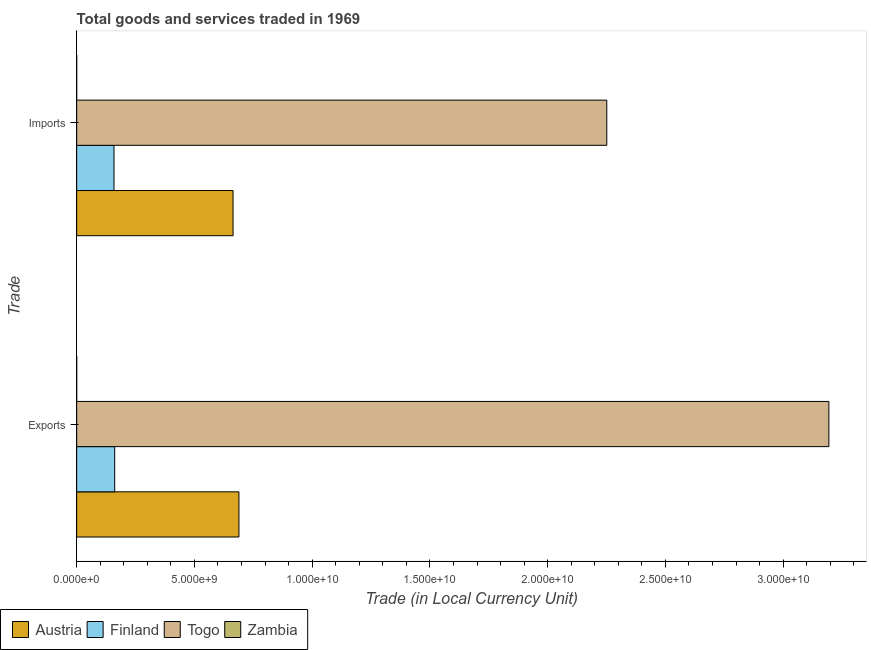How many groups of bars are there?
Keep it short and to the point. 2. How many bars are there on the 2nd tick from the bottom?
Your answer should be very brief. 4. What is the label of the 2nd group of bars from the top?
Ensure brevity in your answer.  Exports. What is the imports of goods and services in Togo?
Give a very brief answer. 2.25e+1. Across all countries, what is the maximum imports of goods and services?
Offer a terse response. 2.25e+1. Across all countries, what is the minimum export of goods and services?
Your response must be concise. 8.63e+05. In which country was the export of goods and services maximum?
Your response must be concise. Togo. In which country was the export of goods and services minimum?
Make the answer very short. Zambia. What is the total imports of goods and services in the graph?
Provide a succinct answer. 3.07e+1. What is the difference between the export of goods and services in Zambia and that in Austria?
Your response must be concise. -6.89e+09. What is the difference between the imports of goods and services in Finland and the export of goods and services in Austria?
Provide a short and direct response. -5.31e+09. What is the average export of goods and services per country?
Give a very brief answer. 1.01e+1. What is the difference between the export of goods and services and imports of goods and services in Zambia?
Provide a succinct answer. 4.37e+05. In how many countries, is the imports of goods and services greater than 7000000000 LCU?
Your answer should be very brief. 1. What is the ratio of the export of goods and services in Finland to that in Austria?
Give a very brief answer. 0.23. Is the export of goods and services in Finland less than that in Austria?
Provide a short and direct response. Yes. In how many countries, is the export of goods and services greater than the average export of goods and services taken over all countries?
Give a very brief answer. 1. What does the 4th bar from the top in Imports represents?
Your answer should be compact. Austria. What does the 4th bar from the bottom in Exports represents?
Offer a terse response. Zambia. Are all the bars in the graph horizontal?
Make the answer very short. Yes. What is the difference between two consecutive major ticks on the X-axis?
Give a very brief answer. 5.00e+09. Does the graph contain any zero values?
Your response must be concise. No. What is the title of the graph?
Your answer should be very brief. Total goods and services traded in 1969. What is the label or title of the X-axis?
Your answer should be compact. Trade (in Local Currency Unit). What is the label or title of the Y-axis?
Your response must be concise. Trade. What is the Trade (in Local Currency Unit) in Austria in Exports?
Keep it short and to the point. 6.89e+09. What is the Trade (in Local Currency Unit) in Finland in Exports?
Your response must be concise. 1.62e+09. What is the Trade (in Local Currency Unit) of Togo in Exports?
Ensure brevity in your answer.  3.19e+1. What is the Trade (in Local Currency Unit) of Zambia in Exports?
Your answer should be very brief. 8.63e+05. What is the Trade (in Local Currency Unit) of Austria in Imports?
Provide a succinct answer. 6.64e+09. What is the Trade (in Local Currency Unit) of Finland in Imports?
Your answer should be compact. 1.58e+09. What is the Trade (in Local Currency Unit) of Togo in Imports?
Ensure brevity in your answer.  2.25e+1. What is the Trade (in Local Currency Unit) in Zambia in Imports?
Give a very brief answer. 4.26e+05. Across all Trade, what is the maximum Trade (in Local Currency Unit) in Austria?
Your answer should be compact. 6.89e+09. Across all Trade, what is the maximum Trade (in Local Currency Unit) of Finland?
Provide a succinct answer. 1.62e+09. Across all Trade, what is the maximum Trade (in Local Currency Unit) of Togo?
Ensure brevity in your answer.  3.19e+1. Across all Trade, what is the maximum Trade (in Local Currency Unit) in Zambia?
Your answer should be very brief. 8.63e+05. Across all Trade, what is the minimum Trade (in Local Currency Unit) of Austria?
Make the answer very short. 6.64e+09. Across all Trade, what is the minimum Trade (in Local Currency Unit) in Finland?
Provide a succinct answer. 1.58e+09. Across all Trade, what is the minimum Trade (in Local Currency Unit) of Togo?
Ensure brevity in your answer.  2.25e+1. Across all Trade, what is the minimum Trade (in Local Currency Unit) in Zambia?
Give a very brief answer. 4.26e+05. What is the total Trade (in Local Currency Unit) in Austria in the graph?
Your response must be concise. 1.35e+1. What is the total Trade (in Local Currency Unit) in Finland in the graph?
Your answer should be compact. 3.20e+09. What is the total Trade (in Local Currency Unit) of Togo in the graph?
Offer a very short reply. 5.45e+1. What is the total Trade (in Local Currency Unit) of Zambia in the graph?
Your response must be concise. 1.29e+06. What is the difference between the Trade (in Local Currency Unit) in Austria in Exports and that in Imports?
Ensure brevity in your answer.  2.49e+08. What is the difference between the Trade (in Local Currency Unit) in Finland in Exports and that in Imports?
Your response must be concise. 3.02e+07. What is the difference between the Trade (in Local Currency Unit) of Togo in Exports and that in Imports?
Offer a very short reply. 9.43e+09. What is the difference between the Trade (in Local Currency Unit) of Zambia in Exports and that in Imports?
Make the answer very short. 4.37e+05. What is the difference between the Trade (in Local Currency Unit) of Austria in Exports and the Trade (in Local Currency Unit) of Finland in Imports?
Provide a short and direct response. 5.31e+09. What is the difference between the Trade (in Local Currency Unit) in Austria in Exports and the Trade (in Local Currency Unit) in Togo in Imports?
Provide a short and direct response. -1.56e+1. What is the difference between the Trade (in Local Currency Unit) of Austria in Exports and the Trade (in Local Currency Unit) of Zambia in Imports?
Keep it short and to the point. 6.89e+09. What is the difference between the Trade (in Local Currency Unit) of Finland in Exports and the Trade (in Local Currency Unit) of Togo in Imports?
Provide a succinct answer. -2.09e+1. What is the difference between the Trade (in Local Currency Unit) in Finland in Exports and the Trade (in Local Currency Unit) in Zambia in Imports?
Your answer should be very brief. 1.61e+09. What is the difference between the Trade (in Local Currency Unit) of Togo in Exports and the Trade (in Local Currency Unit) of Zambia in Imports?
Provide a succinct answer. 3.19e+1. What is the average Trade (in Local Currency Unit) of Austria per Trade?
Your answer should be very brief. 6.77e+09. What is the average Trade (in Local Currency Unit) in Finland per Trade?
Offer a terse response. 1.60e+09. What is the average Trade (in Local Currency Unit) of Togo per Trade?
Ensure brevity in your answer.  2.72e+1. What is the average Trade (in Local Currency Unit) of Zambia per Trade?
Provide a succinct answer. 6.44e+05. What is the difference between the Trade (in Local Currency Unit) of Austria and Trade (in Local Currency Unit) of Finland in Exports?
Provide a succinct answer. 5.28e+09. What is the difference between the Trade (in Local Currency Unit) in Austria and Trade (in Local Currency Unit) in Togo in Exports?
Your response must be concise. -2.51e+1. What is the difference between the Trade (in Local Currency Unit) of Austria and Trade (in Local Currency Unit) of Zambia in Exports?
Make the answer very short. 6.89e+09. What is the difference between the Trade (in Local Currency Unit) of Finland and Trade (in Local Currency Unit) of Togo in Exports?
Offer a terse response. -3.03e+1. What is the difference between the Trade (in Local Currency Unit) of Finland and Trade (in Local Currency Unit) of Zambia in Exports?
Give a very brief answer. 1.61e+09. What is the difference between the Trade (in Local Currency Unit) in Togo and Trade (in Local Currency Unit) in Zambia in Exports?
Keep it short and to the point. 3.19e+1. What is the difference between the Trade (in Local Currency Unit) of Austria and Trade (in Local Currency Unit) of Finland in Imports?
Give a very brief answer. 5.06e+09. What is the difference between the Trade (in Local Currency Unit) in Austria and Trade (in Local Currency Unit) in Togo in Imports?
Provide a short and direct response. -1.59e+1. What is the difference between the Trade (in Local Currency Unit) in Austria and Trade (in Local Currency Unit) in Zambia in Imports?
Make the answer very short. 6.64e+09. What is the difference between the Trade (in Local Currency Unit) in Finland and Trade (in Local Currency Unit) in Togo in Imports?
Ensure brevity in your answer.  -2.09e+1. What is the difference between the Trade (in Local Currency Unit) of Finland and Trade (in Local Currency Unit) of Zambia in Imports?
Provide a succinct answer. 1.58e+09. What is the difference between the Trade (in Local Currency Unit) of Togo and Trade (in Local Currency Unit) of Zambia in Imports?
Provide a short and direct response. 2.25e+1. What is the ratio of the Trade (in Local Currency Unit) in Austria in Exports to that in Imports?
Offer a terse response. 1.04. What is the ratio of the Trade (in Local Currency Unit) of Finland in Exports to that in Imports?
Your answer should be compact. 1.02. What is the ratio of the Trade (in Local Currency Unit) of Togo in Exports to that in Imports?
Your response must be concise. 1.42. What is the ratio of the Trade (in Local Currency Unit) in Zambia in Exports to that in Imports?
Give a very brief answer. 2.03. What is the difference between the highest and the second highest Trade (in Local Currency Unit) in Austria?
Provide a short and direct response. 2.49e+08. What is the difference between the highest and the second highest Trade (in Local Currency Unit) of Finland?
Offer a very short reply. 3.02e+07. What is the difference between the highest and the second highest Trade (in Local Currency Unit) in Togo?
Provide a succinct answer. 9.43e+09. What is the difference between the highest and the second highest Trade (in Local Currency Unit) of Zambia?
Your response must be concise. 4.37e+05. What is the difference between the highest and the lowest Trade (in Local Currency Unit) of Austria?
Keep it short and to the point. 2.49e+08. What is the difference between the highest and the lowest Trade (in Local Currency Unit) of Finland?
Make the answer very short. 3.02e+07. What is the difference between the highest and the lowest Trade (in Local Currency Unit) of Togo?
Make the answer very short. 9.43e+09. What is the difference between the highest and the lowest Trade (in Local Currency Unit) in Zambia?
Keep it short and to the point. 4.37e+05. 